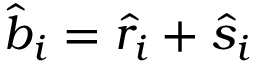Convert formula to latex. <formula><loc_0><loc_0><loc_500><loc_500>\hat { b } _ { i } = \hat { r } _ { i } + \hat { s } _ { i }</formula> 